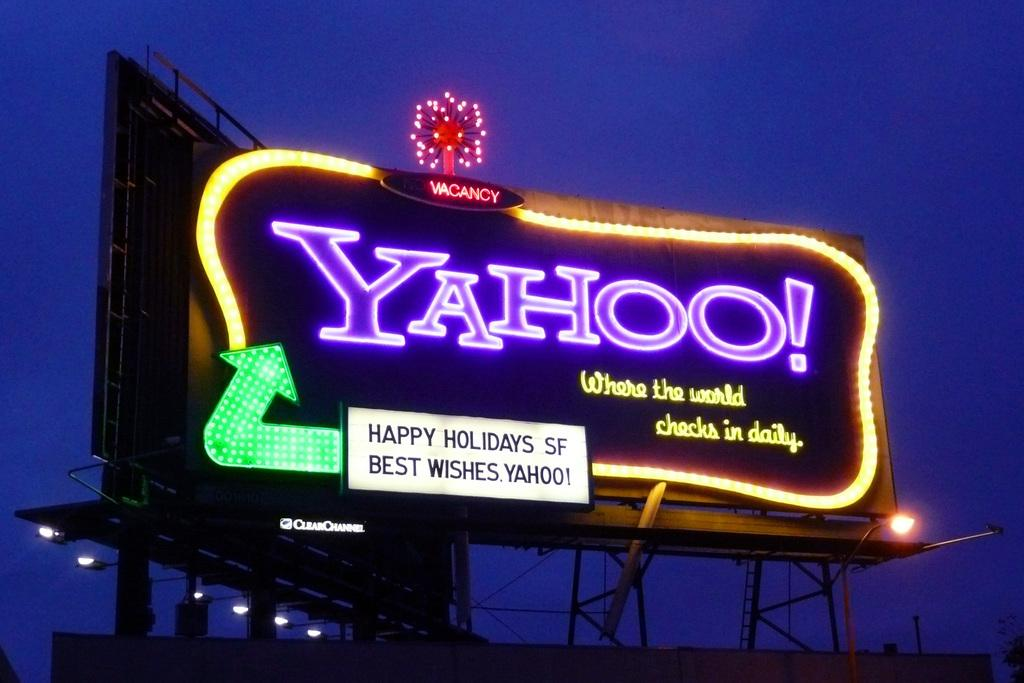<image>
Relay a brief, clear account of the picture shown. A billboard for Yahoo! that wishes Happy Holidays to San Francisco 